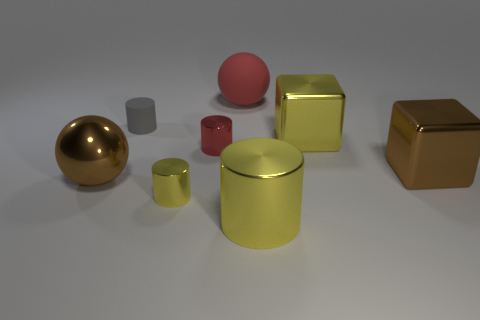Subtract all rubber cylinders. How many cylinders are left? 3 Subtract all red cylinders. How many cylinders are left? 3 Subtract all purple cylinders. Subtract all cyan blocks. How many cylinders are left? 4 Add 1 large green blocks. How many objects exist? 9 Subtract all blocks. How many objects are left? 6 Subtract 0 green cubes. How many objects are left? 8 Subtract all small shiny cylinders. Subtract all big red matte spheres. How many objects are left? 5 Add 1 big things. How many big things are left? 6 Add 3 big yellow objects. How many big yellow objects exist? 5 